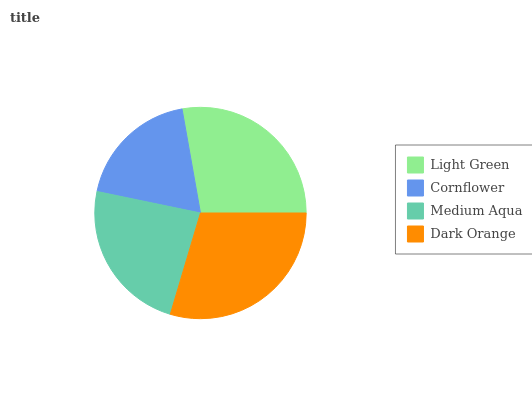Is Cornflower the minimum?
Answer yes or no. Yes. Is Dark Orange the maximum?
Answer yes or no. Yes. Is Medium Aqua the minimum?
Answer yes or no. No. Is Medium Aqua the maximum?
Answer yes or no. No. Is Medium Aqua greater than Cornflower?
Answer yes or no. Yes. Is Cornflower less than Medium Aqua?
Answer yes or no. Yes. Is Cornflower greater than Medium Aqua?
Answer yes or no. No. Is Medium Aqua less than Cornflower?
Answer yes or no. No. Is Light Green the high median?
Answer yes or no. Yes. Is Medium Aqua the low median?
Answer yes or no. Yes. Is Dark Orange the high median?
Answer yes or no. No. Is Cornflower the low median?
Answer yes or no. No. 